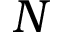<formula> <loc_0><loc_0><loc_500><loc_500>N</formula> 